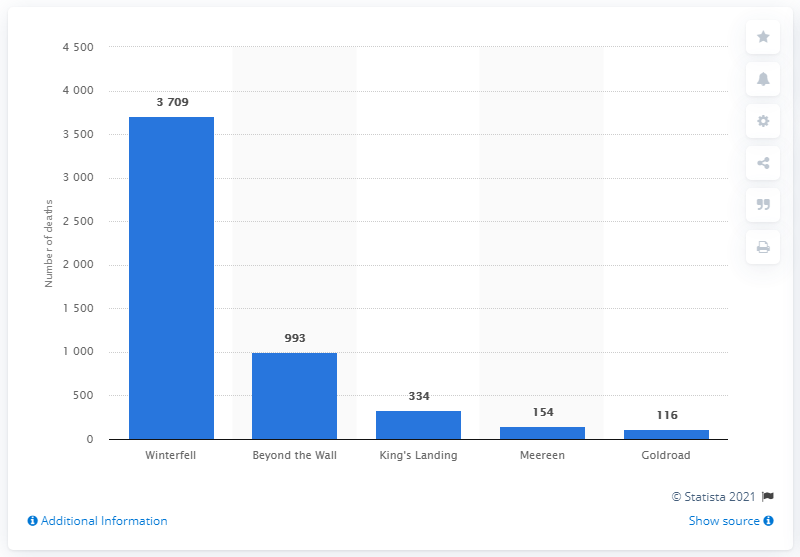Point out several critical features in this image. Winterfell was the deadliest location on Game of Thrones. 